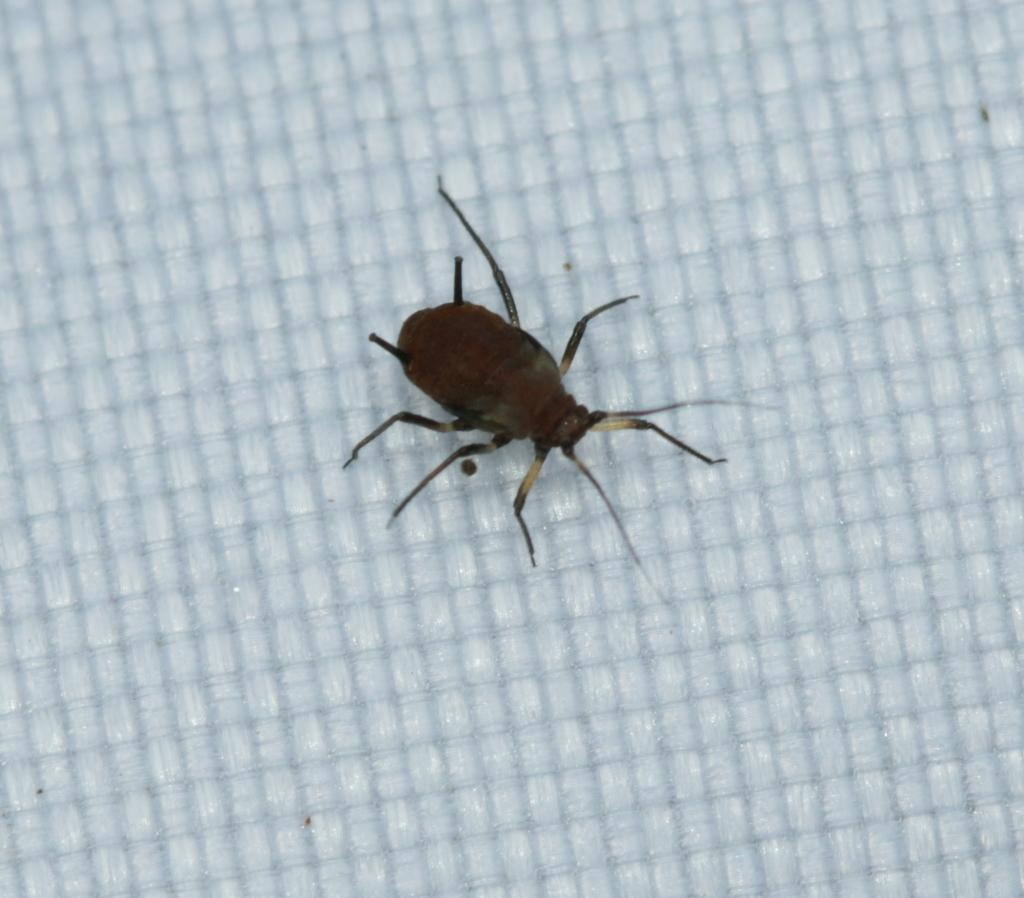What type of creature is present in the image? There is an insect in the image. What type of skirt is the insect wearing in the image? There is no skirt present in the image, as insects do not wear clothing. 